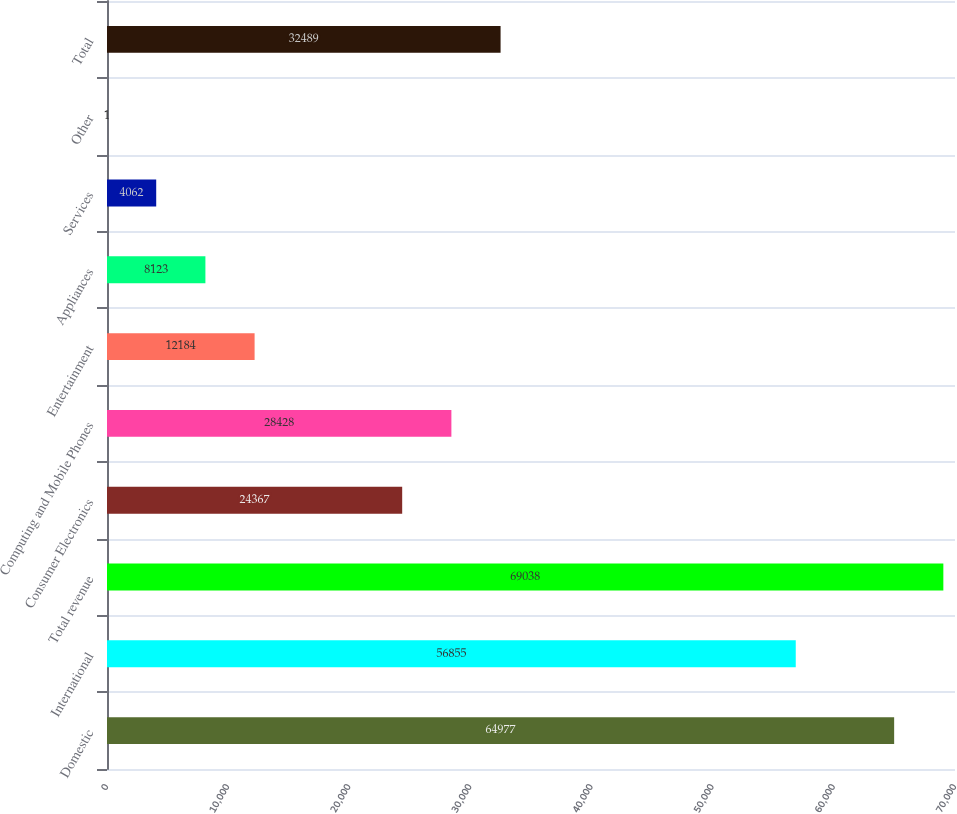<chart> <loc_0><loc_0><loc_500><loc_500><bar_chart><fcel>Domestic<fcel>International<fcel>Total revenue<fcel>Consumer Electronics<fcel>Computing and Mobile Phones<fcel>Entertainment<fcel>Appliances<fcel>Services<fcel>Other<fcel>Total<nl><fcel>64977<fcel>56855<fcel>69038<fcel>24367<fcel>28428<fcel>12184<fcel>8123<fcel>4062<fcel>1<fcel>32489<nl></chart> 